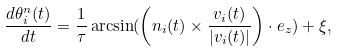Convert formula to latex. <formula><loc_0><loc_0><loc_500><loc_500>\frac { d \theta ^ { n } _ { i } ( t ) } { d t } = \frac { 1 } { \tau } \arcsin ( \left ( { n } _ { i } ( t ) \times \frac { { v } _ { i } ( t ) } { | { v } _ { i } ( t ) | } \right ) \cdot { e } _ { z } ) + \xi ,</formula> 